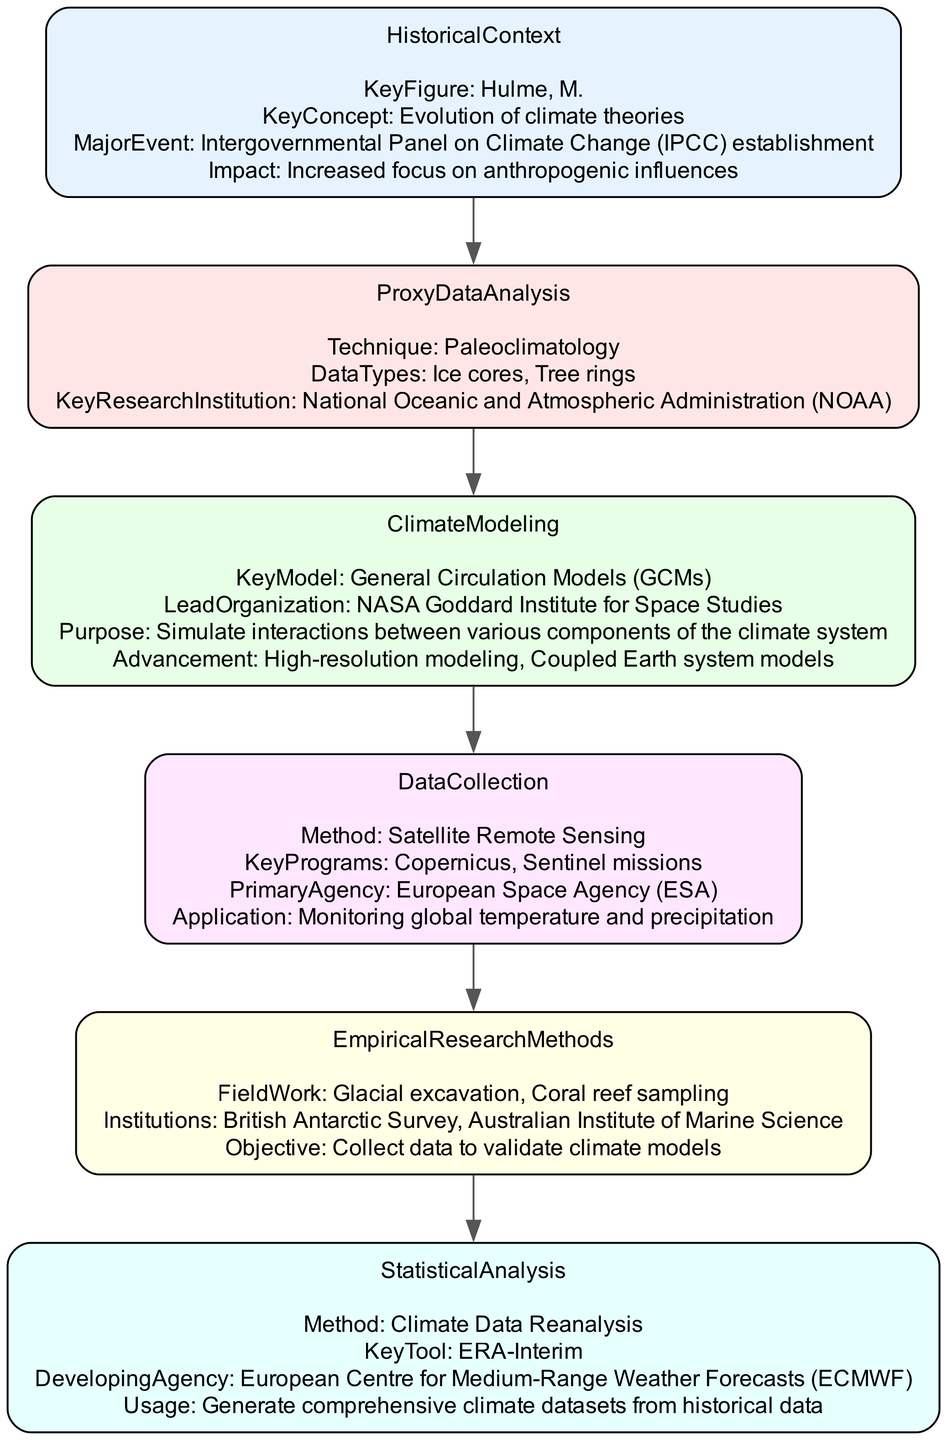What is the key figure associated with the historical context of climate change research? The diagram indicates that the key figure is "Hulme, M." associated with the "Historical Context" stage.
Answer: Hulme, M How many major research advancements are listed in the diagram? The diagram contains six nodes representing six significant advancements in climate change research methods, each corresponding to a stage in the clinical pathway.
Answer: 6 What technique is identified in the Proxy Data Analysis stage? The diagram highlights "Paleoclimatology" as the technique in the "Proxy Data Analysis" stage, indicating its relevance in climate research.
Answer: Paleoclimatology Which organization leads the climate modeling efforts according to the diagram? According to the diagram, the "NASA Goddard Institute for Space Studies" is identified as the leading organization in the "Climate Modeling" stage.
Answer: NASA Goddard Institute for Space Studies What type of data does the Statistical Analysis stage focus on? The diagram specifies that the Statistical Analysis stage employs "Climate Data Reanalysis," which focuses on creating comprehensive datasets from historical climate data.
Answer: Climate Data Reanalysis What is the primary agency for satellite remote sensing applications? The diagram details that the "European Space Agency (ESA)" is the primary agency responsible for satellite remote sensing and associated programs.
Answer: European Space Agency What is one advancement mentioned under climate modeling? Within the "Climate Modeling" section, the diagram lists "High-resolution modeling" as one of the advancements, emphasizing improvements in simulation accuracy and detail.
Answer: High-resolution modeling What key tool is mentioned for climate data reanalysis? The key tool highlighted in the "Statistical Analysis" stage for reanalyzing climate data is "ERA-Interim." This highlights its significance in generating climate data.
Answer: ERA-Interim What applications does satellite remote sensing monitor? The diagram states that satellite remote sensing is applied for "Monitoring global temperature and precipitation," showcasing its operational use in climate assessment.
Answer: Monitoring global temperature and precipitation 